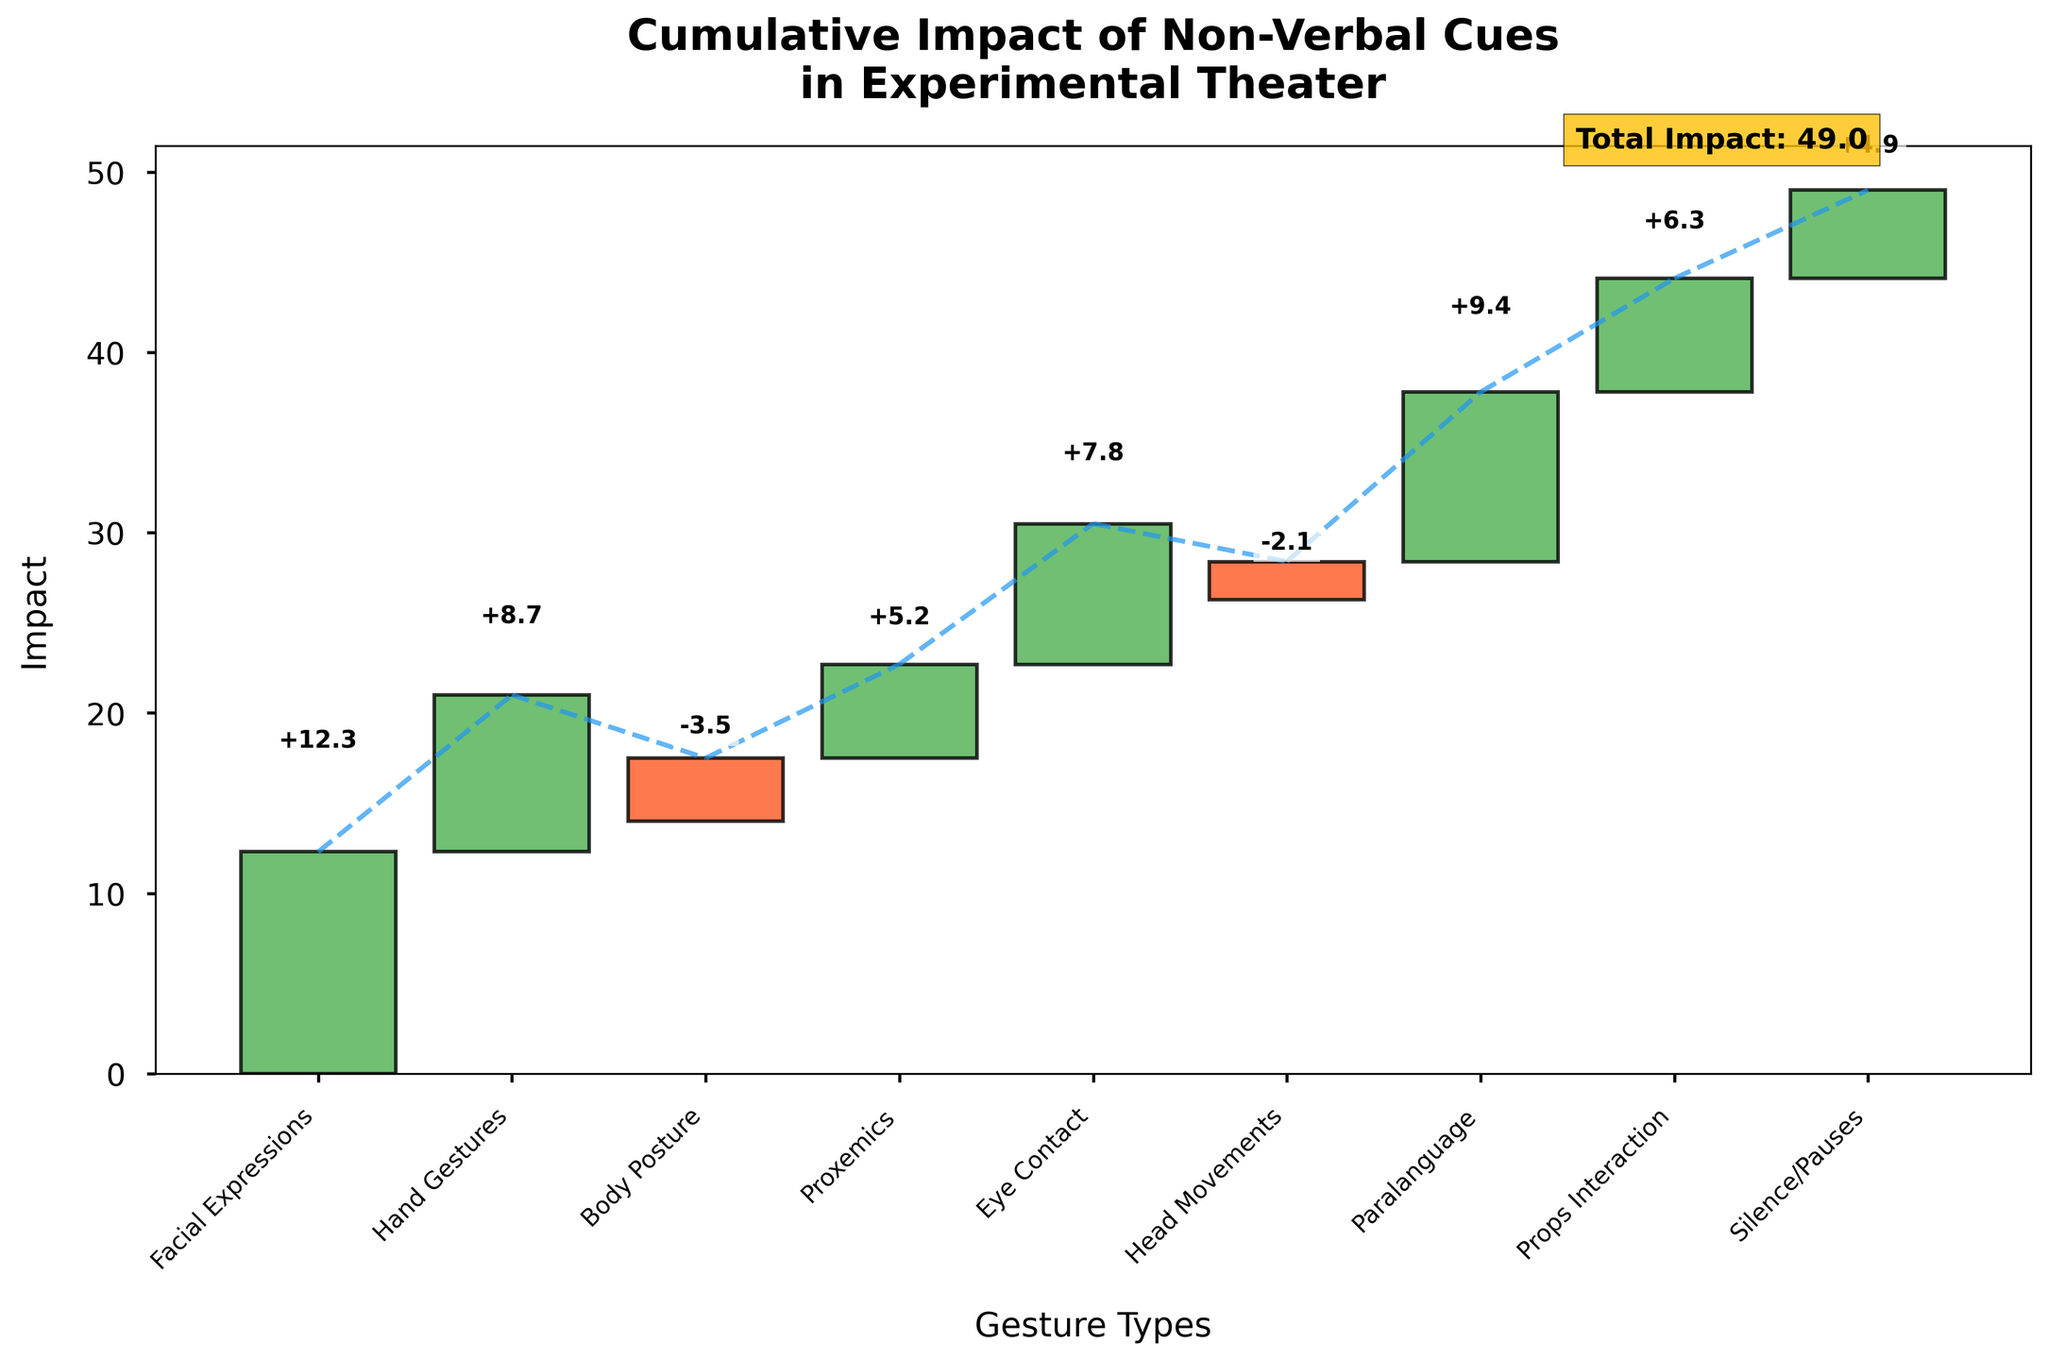What is the title of the plot? The title of the plot is displayed at the top of the figure, and it reads "Cumulative Impact of Non-Verbal Cues in Experimental Theater"
Answer: Cumulative Impact of Non-Verbal Cues in Experimental Theater What is the total impact value shown in the plot? The total impact value is located at the end of the plot, with a corresponding label that reads "Total Impact: 49"
Answer: 49 Which non-verbal cue has the highest positive impact? Among the bars representing different non-verbal cues, "Facial Expressions" has the highest positive impact with a value of +12.3
Answer: Facial Expressions What is the impact of hand gestures on audience interpretation? Hand Gestures has a value labeled as +8.7 in the figure, positioned as the second cue from the left
Answer: +8.7 Which non-verbal cue has the lowest impact? The bar for "Head Movements" has the lowest value, showing an impact of -2.1
Answer: Head Movements How many non-verbal cues have a negative impact? The plot shows bars with negative values for "Body Posture" (-3.5) and "Head Movements" (-2.1), indicating two non-verbal cues with negative impacts
Answer: 2 What is the combined impact of "Proxemics" and "Eye Contact"? The impact of Proxemics is +5.2 and the impact of Eye Contact is +7.8. Together, their combined impact is calculated as 5.2 + 7.8 = 13.0
Answer: 13.0 What is the difference in impact between the highest and the lowest non-verbal cues? The highest impact is from "Facial Expressions" at +12.3, and the lowest is from "Head Movements" at -2.1. The difference is calculated as 12.3 - (-2.1) = 14.4
Answer: 14.4 Which non-verbal cues have an impact greater than +5? The non-verbal cues with impacts greater than +5 are "Facial Expressions" (+12.3), "Hand Gestures" (+8.7), "Eye Contact" (+7.8), "Paralanguage" (+9.4), and "Props Interaction" (+6.3)
Answer: Facial Expressions, Hand Gestures, Eye Contact, Paralanguage, Props Interaction What is the sum of all positive impacts shown in the plot? Adding all the positive impacts: 12.3 (Facial Expressions) + 8.7 (Hand Gestures) + 5.2 (Proxemics) + 7.8 (Eye Contact) + 9.4 (Paralanguage) + 6.3 (Props Interaction) + 4.9 (Silence/Pauses) results in a sum of 54.6
Answer: 54.6 